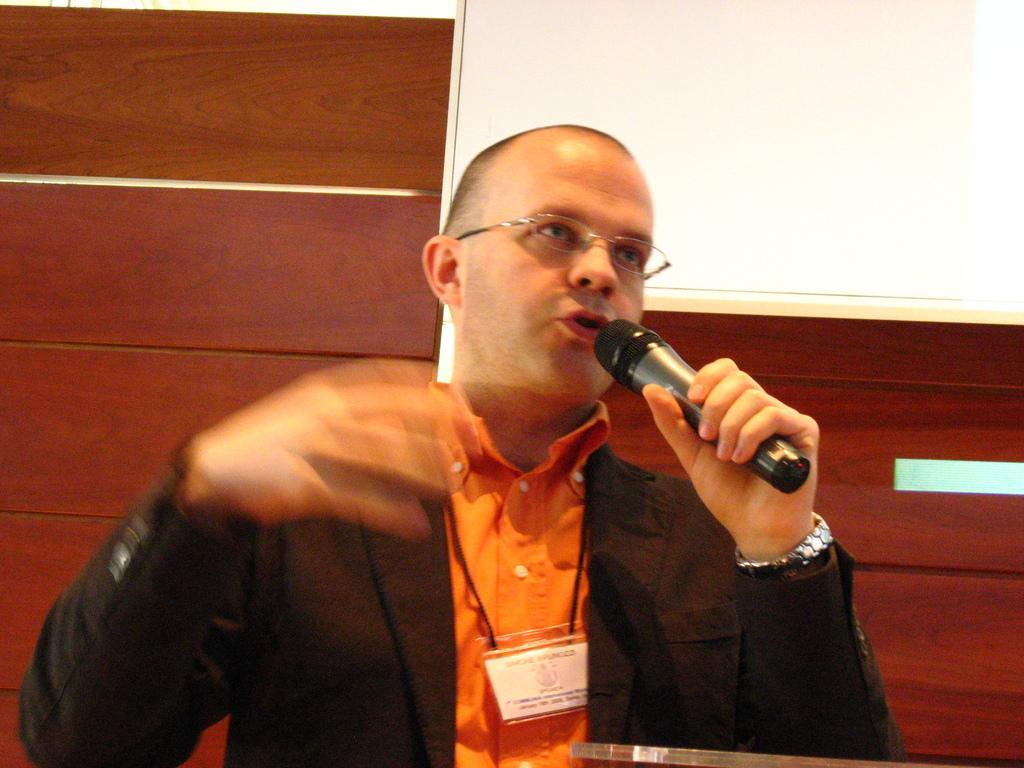In one or two sentences, can you explain what this image depicts? In the image we can see a man wearing clothes, wrist watch and spectacles. The man is holding a microphone in his hand. There is a white board and a wooden wall. 